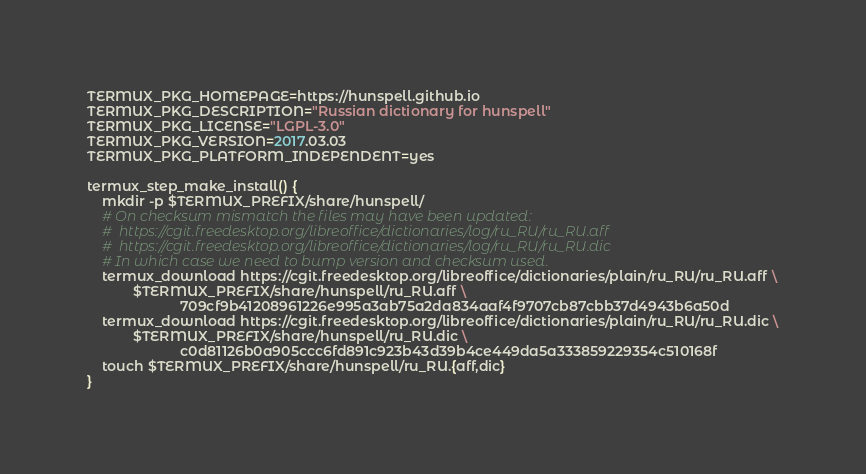Convert code to text. <code><loc_0><loc_0><loc_500><loc_500><_Bash_>TERMUX_PKG_HOMEPAGE=https://hunspell.github.io
TERMUX_PKG_DESCRIPTION="Russian dictionary for hunspell"
TERMUX_PKG_LICENSE="LGPL-3.0"
TERMUX_PKG_VERSION=2017.03.03
TERMUX_PKG_PLATFORM_INDEPENDENT=yes

termux_step_make_install() {
	mkdir -p $TERMUX_PREFIX/share/hunspell/
	# On checksum mismatch the files may have been updated:
	#  https://cgit.freedesktop.org/libreoffice/dictionaries/log/ru_RU/ru_RU.aff
	#  https://cgit.freedesktop.org/libreoffice/dictionaries/log/ru_RU/ru_RU.dic
	# In which case we need to bump version and checksum used.
	termux_download https://cgit.freedesktop.org/libreoffice/dictionaries/plain/ru_RU/ru_RU.aff \
			$TERMUX_PREFIX/share/hunspell/ru_RU.aff \
                        709cf9b41208961226e995a3ab75a2da834aaf4f9707cb87cbb37d4943b6a50d
	termux_download https://cgit.freedesktop.org/libreoffice/dictionaries/plain/ru_RU/ru_RU.dic \
			$TERMUX_PREFIX/share/hunspell/ru_RU.dic \
                        c0d81126b0a905ccc6fd891c923b43d39b4ce449da5a333859229354c510168f
	touch $TERMUX_PREFIX/share/hunspell/ru_RU.{aff,dic}
}
</code> 